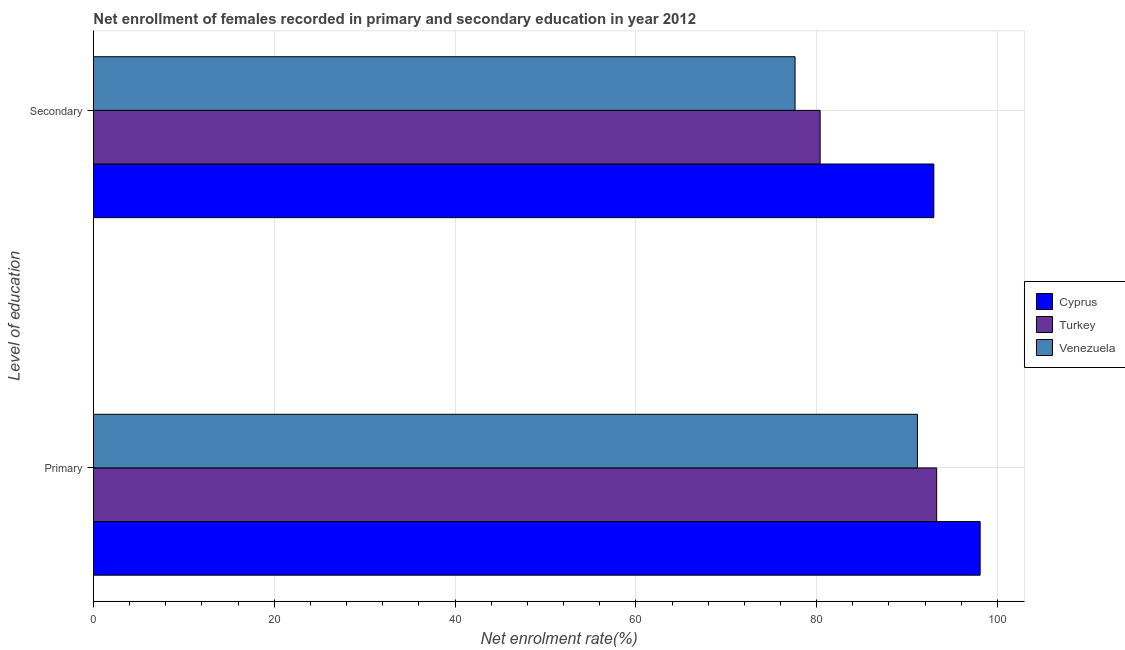How many different coloured bars are there?
Your answer should be very brief. 3. How many groups of bars are there?
Your answer should be very brief. 2. Are the number of bars per tick equal to the number of legend labels?
Your answer should be very brief. Yes. Are the number of bars on each tick of the Y-axis equal?
Provide a succinct answer. Yes. What is the label of the 1st group of bars from the top?
Give a very brief answer. Secondary. What is the enrollment rate in secondary education in Cyprus?
Offer a very short reply. 92.97. Across all countries, what is the maximum enrollment rate in secondary education?
Your answer should be very brief. 92.97. Across all countries, what is the minimum enrollment rate in primary education?
Your response must be concise. 91.15. In which country was the enrollment rate in secondary education maximum?
Make the answer very short. Cyprus. In which country was the enrollment rate in secondary education minimum?
Provide a succinct answer. Venezuela. What is the total enrollment rate in secondary education in the graph?
Your answer should be very brief. 250.97. What is the difference between the enrollment rate in secondary education in Turkey and that in Cyprus?
Ensure brevity in your answer.  -12.58. What is the difference between the enrollment rate in secondary education in Cyprus and the enrollment rate in primary education in Venezuela?
Your response must be concise. 1.82. What is the average enrollment rate in secondary education per country?
Ensure brevity in your answer.  83.66. What is the difference between the enrollment rate in primary education and enrollment rate in secondary education in Cyprus?
Make the answer very short. 5.12. In how many countries, is the enrollment rate in secondary education greater than 68 %?
Your answer should be compact. 3. What is the ratio of the enrollment rate in primary education in Cyprus to that in Venezuela?
Your answer should be very brief. 1.08. What does the 2nd bar from the top in Primary represents?
Your answer should be compact. Turkey. What does the 3rd bar from the bottom in Primary represents?
Offer a very short reply. Venezuela. Are all the bars in the graph horizontal?
Make the answer very short. Yes. Does the graph contain any zero values?
Provide a succinct answer. No. How many legend labels are there?
Provide a succinct answer. 3. What is the title of the graph?
Provide a short and direct response. Net enrollment of females recorded in primary and secondary education in year 2012. Does "South Africa" appear as one of the legend labels in the graph?
Ensure brevity in your answer.  No. What is the label or title of the X-axis?
Keep it short and to the point. Net enrolment rate(%). What is the label or title of the Y-axis?
Keep it short and to the point. Level of education. What is the Net enrolment rate(%) of Cyprus in Primary?
Keep it short and to the point. 98.09. What is the Net enrolment rate(%) in Turkey in Primary?
Provide a succinct answer. 93.28. What is the Net enrolment rate(%) in Venezuela in Primary?
Provide a short and direct response. 91.15. What is the Net enrolment rate(%) of Cyprus in Secondary?
Provide a short and direct response. 92.97. What is the Net enrolment rate(%) of Turkey in Secondary?
Provide a succinct answer. 80.39. What is the Net enrolment rate(%) in Venezuela in Secondary?
Provide a short and direct response. 77.61. Across all Level of education, what is the maximum Net enrolment rate(%) of Cyprus?
Offer a terse response. 98.09. Across all Level of education, what is the maximum Net enrolment rate(%) of Turkey?
Your answer should be compact. 93.28. Across all Level of education, what is the maximum Net enrolment rate(%) in Venezuela?
Give a very brief answer. 91.15. Across all Level of education, what is the minimum Net enrolment rate(%) of Cyprus?
Give a very brief answer. 92.97. Across all Level of education, what is the minimum Net enrolment rate(%) of Turkey?
Offer a terse response. 80.39. Across all Level of education, what is the minimum Net enrolment rate(%) of Venezuela?
Your response must be concise. 77.61. What is the total Net enrolment rate(%) in Cyprus in the graph?
Your answer should be compact. 191.05. What is the total Net enrolment rate(%) of Turkey in the graph?
Your response must be concise. 173.67. What is the total Net enrolment rate(%) of Venezuela in the graph?
Your response must be concise. 168.76. What is the difference between the Net enrolment rate(%) of Cyprus in Primary and that in Secondary?
Provide a short and direct response. 5.12. What is the difference between the Net enrolment rate(%) in Turkey in Primary and that in Secondary?
Ensure brevity in your answer.  12.89. What is the difference between the Net enrolment rate(%) in Venezuela in Primary and that in Secondary?
Ensure brevity in your answer.  13.54. What is the difference between the Net enrolment rate(%) of Cyprus in Primary and the Net enrolment rate(%) of Turkey in Secondary?
Ensure brevity in your answer.  17.7. What is the difference between the Net enrolment rate(%) in Cyprus in Primary and the Net enrolment rate(%) in Venezuela in Secondary?
Provide a short and direct response. 20.47. What is the difference between the Net enrolment rate(%) in Turkey in Primary and the Net enrolment rate(%) in Venezuela in Secondary?
Offer a terse response. 15.67. What is the average Net enrolment rate(%) in Cyprus per Level of education?
Ensure brevity in your answer.  95.53. What is the average Net enrolment rate(%) of Turkey per Level of education?
Make the answer very short. 86.83. What is the average Net enrolment rate(%) in Venezuela per Level of education?
Your answer should be very brief. 84.38. What is the difference between the Net enrolment rate(%) in Cyprus and Net enrolment rate(%) in Turkey in Primary?
Keep it short and to the point. 4.81. What is the difference between the Net enrolment rate(%) of Cyprus and Net enrolment rate(%) of Venezuela in Primary?
Offer a very short reply. 6.94. What is the difference between the Net enrolment rate(%) in Turkey and Net enrolment rate(%) in Venezuela in Primary?
Make the answer very short. 2.13. What is the difference between the Net enrolment rate(%) of Cyprus and Net enrolment rate(%) of Turkey in Secondary?
Keep it short and to the point. 12.58. What is the difference between the Net enrolment rate(%) of Cyprus and Net enrolment rate(%) of Venezuela in Secondary?
Provide a succinct answer. 15.35. What is the difference between the Net enrolment rate(%) of Turkey and Net enrolment rate(%) of Venezuela in Secondary?
Offer a very short reply. 2.77. What is the ratio of the Net enrolment rate(%) of Cyprus in Primary to that in Secondary?
Provide a short and direct response. 1.06. What is the ratio of the Net enrolment rate(%) of Turkey in Primary to that in Secondary?
Your answer should be compact. 1.16. What is the ratio of the Net enrolment rate(%) in Venezuela in Primary to that in Secondary?
Offer a terse response. 1.17. What is the difference between the highest and the second highest Net enrolment rate(%) of Cyprus?
Offer a very short reply. 5.12. What is the difference between the highest and the second highest Net enrolment rate(%) in Turkey?
Your answer should be very brief. 12.89. What is the difference between the highest and the second highest Net enrolment rate(%) of Venezuela?
Offer a very short reply. 13.54. What is the difference between the highest and the lowest Net enrolment rate(%) of Cyprus?
Offer a terse response. 5.12. What is the difference between the highest and the lowest Net enrolment rate(%) of Turkey?
Your answer should be very brief. 12.89. What is the difference between the highest and the lowest Net enrolment rate(%) of Venezuela?
Provide a succinct answer. 13.54. 